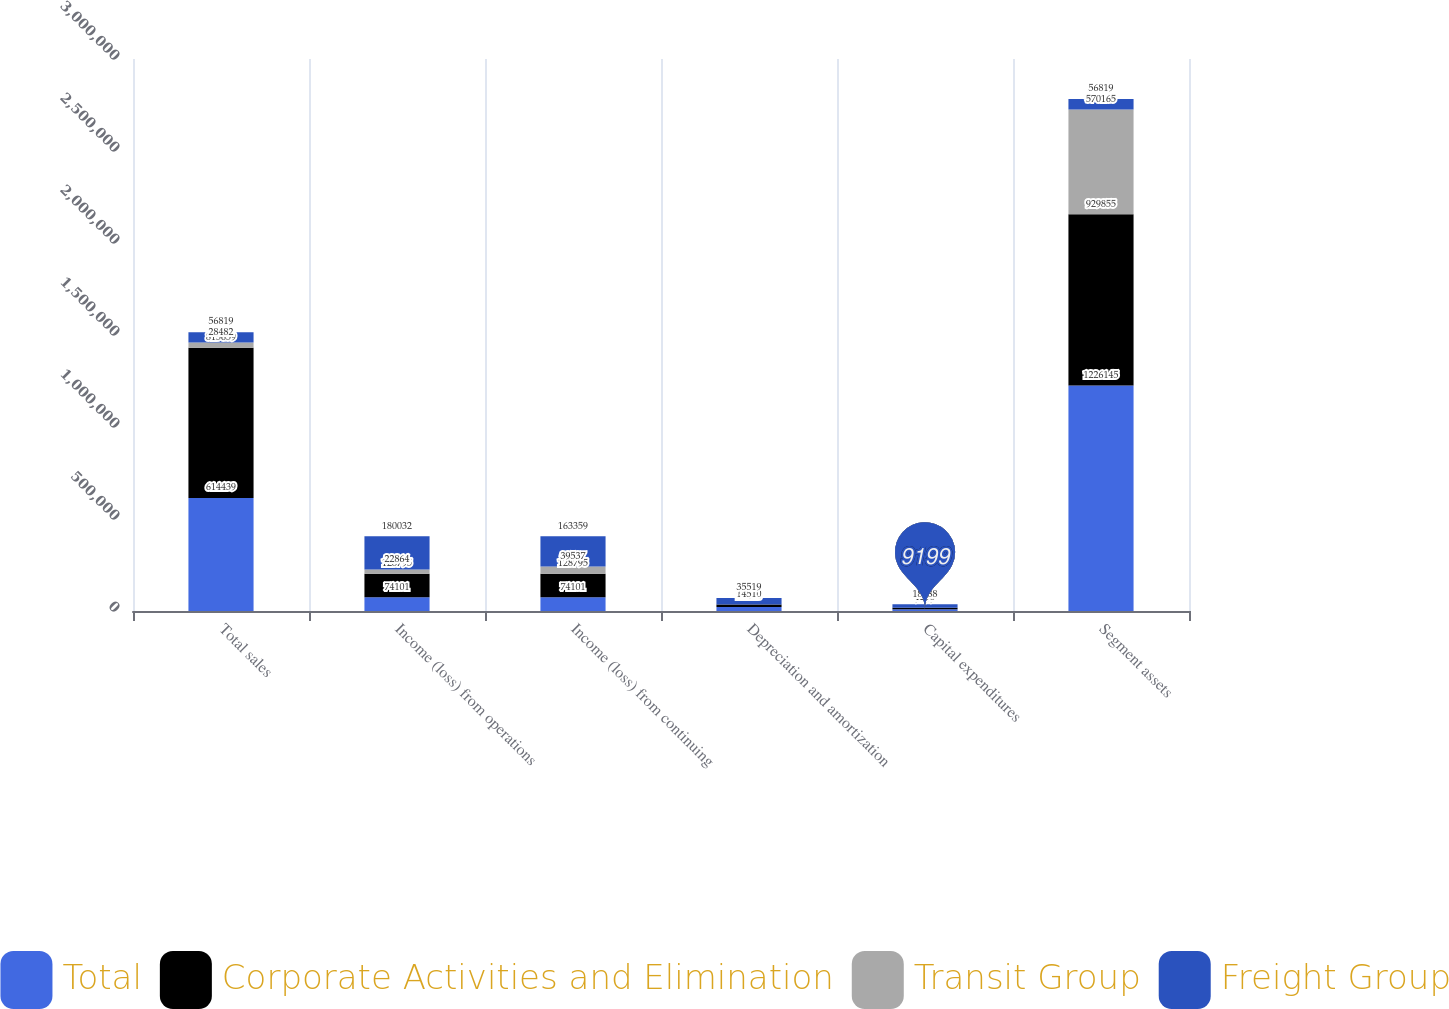Convert chart. <chart><loc_0><loc_0><loc_500><loc_500><stacked_bar_chart><ecel><fcel>Total sales<fcel>Income (loss) from operations<fcel>Income (loss) from continuing<fcel>Depreciation and amortization<fcel>Capital expenditures<fcel>Segment assets<nl><fcel>Total<fcel>614439<fcel>74101<fcel>74101<fcel>22128<fcel>9199<fcel>1.22614e+06<nl><fcel>Corporate Activities and Elimination<fcel>815659<fcel>128795<fcel>128795<fcel>12940<fcel>7791<fcel>929855<nl><fcel>Transit Group<fcel>28482<fcel>22864<fcel>39537<fcel>451<fcel>1298<fcel>570165<nl><fcel>Freight Group<fcel>56819<fcel>180032<fcel>163359<fcel>35519<fcel>18288<fcel>56819<nl></chart> 